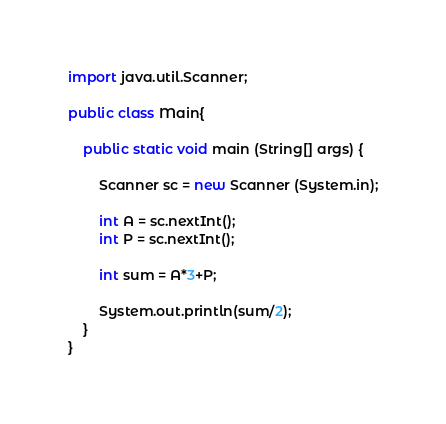Convert code to text. <code><loc_0><loc_0><loc_500><loc_500><_Java_>import java.util.Scanner;

public class Main{

	public static void main (String[] args) {

		Scanner sc = new Scanner (System.in);

		int A = sc.nextInt();
		int P = sc.nextInt();
		
		int sum = A*3+P;
		
		System.out.println(sum/2);
	}
}</code> 